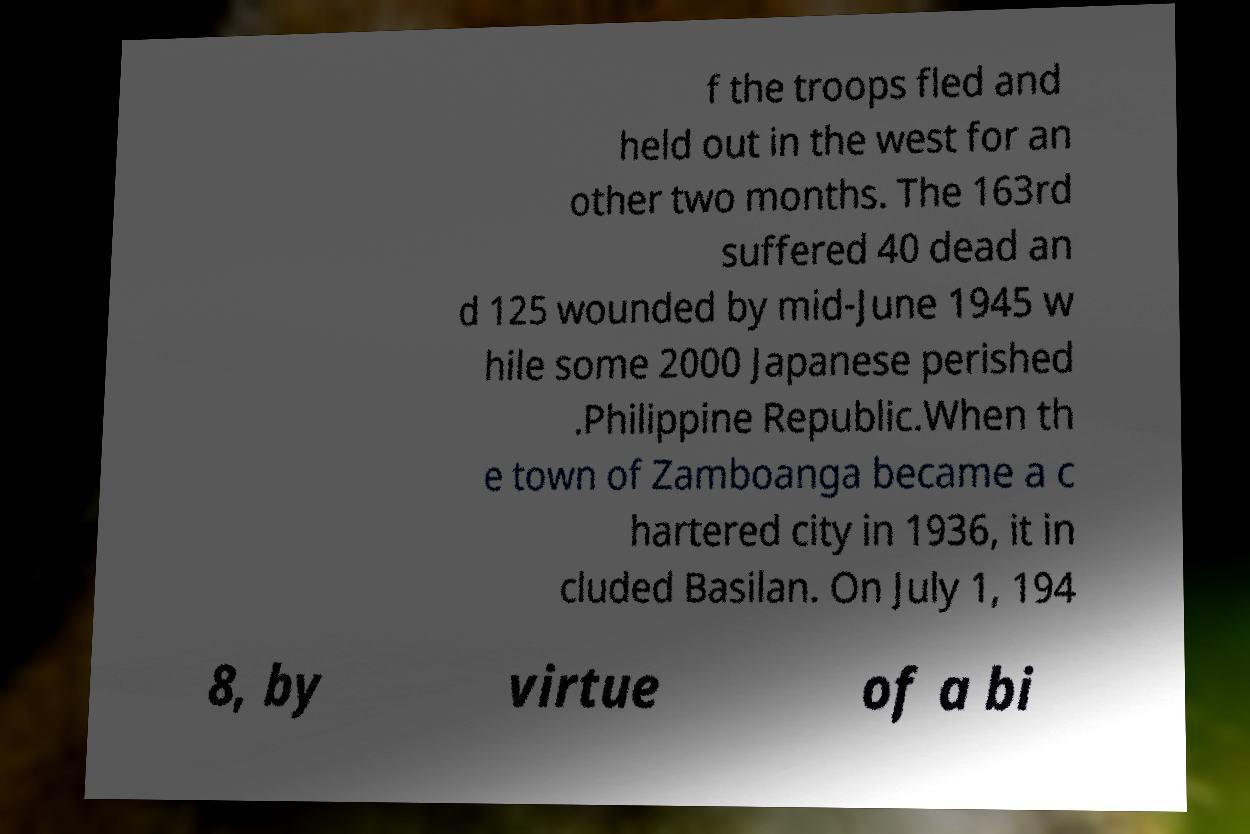I need the written content from this picture converted into text. Can you do that? f the troops fled and held out in the west for an other two months. The 163rd suffered 40 dead an d 125 wounded by mid-June 1945 w hile some 2000 Japanese perished .Philippine Republic.When th e town of Zamboanga became a c hartered city in 1936, it in cluded Basilan. On July 1, 194 8, by virtue of a bi 